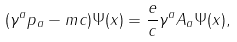<formula> <loc_0><loc_0><loc_500><loc_500>( \gamma ^ { a } p _ { a } - m c ) \Psi ( x ) = \frac { e } { c } \gamma ^ { a } A _ { a } \Psi ( x ) ,</formula> 